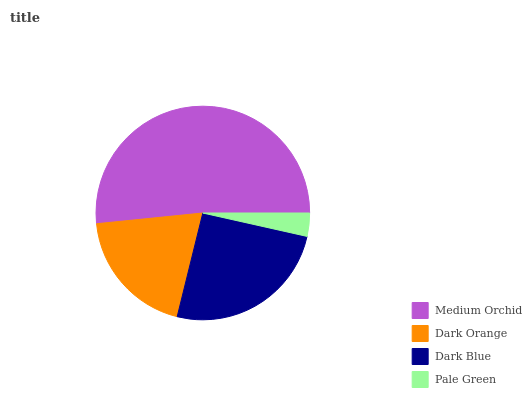Is Pale Green the minimum?
Answer yes or no. Yes. Is Medium Orchid the maximum?
Answer yes or no. Yes. Is Dark Orange the minimum?
Answer yes or no. No. Is Dark Orange the maximum?
Answer yes or no. No. Is Medium Orchid greater than Dark Orange?
Answer yes or no. Yes. Is Dark Orange less than Medium Orchid?
Answer yes or no. Yes. Is Dark Orange greater than Medium Orchid?
Answer yes or no. No. Is Medium Orchid less than Dark Orange?
Answer yes or no. No. Is Dark Blue the high median?
Answer yes or no. Yes. Is Dark Orange the low median?
Answer yes or no. Yes. Is Dark Orange the high median?
Answer yes or no. No. Is Pale Green the low median?
Answer yes or no. No. 